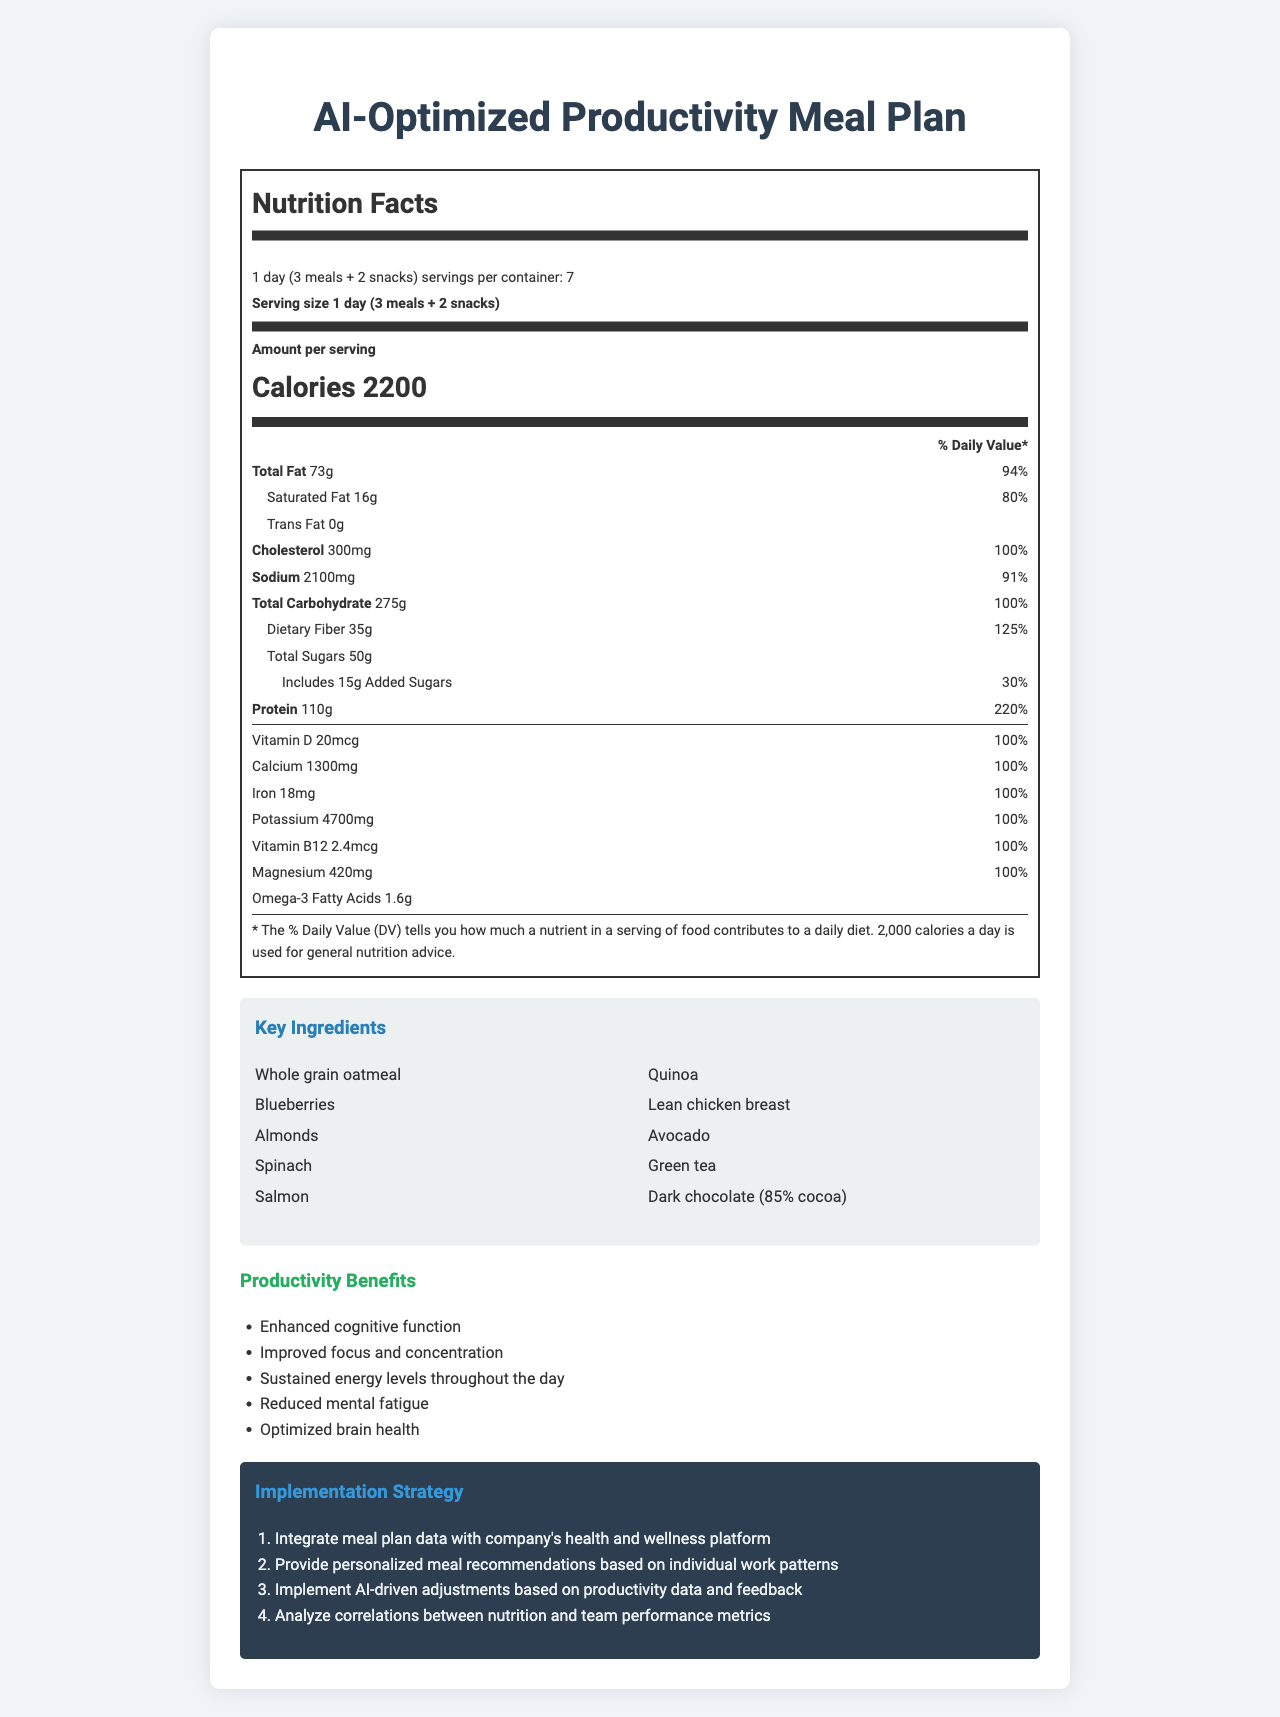what is the serving size for the AI-Optimized Productivity Meal Plan? The serving size is specified in the document under "Nutrition Facts" as "1 day (3 meals + 2 snacks)".
Answer: 1 day (3 meals + 2 snacks) How many calories are there per serving? According to the document, each serving contains 2200 calories.
Answer: 2200 What is the total amount of protein in one serving, and what percentage of the daily value does it represent? The protein amount per serving is listed as 110g with a daily value percentage of 220%.
Answer: 110g and 220% Which key ingredient is rich in Omega-3 fatty acids? Salmon is specifically mentioned as providing Omega-3 fatty acids as part of the key ingredients.
Answer: Salmon What are the AI recommendations for the afternoon snack? The AI recommendations for the afternoon snack include green tea and dark chocolate for improved focus.
Answer: Green tea and dark chocolate for improved focus How much dietary fiber is in one serving, and what is its daily value percentage? Dietary fiber is listed in the document as 35g per serving, which represents 125% of the daily value.
Answer: 35g and 125% How many servings per container are there? A. 5 B. 6 C. 7 D. 8 The document specifies that there are 7 servings per container.
Answer: C. 7 Which of the following is NOT listed as one of the productivity benefits? A. Reduced mental fatigue B. Improved physical performance C. Enhanced cognitive function D. Sustained energy levels The listed productivity benefits include A, C, and D but do not mention improved physical performance.
Answer: B. Improved physical performance Does the meal plan accommodate vegan dietary restrictions? Yes/No The customization options include vegan dietary restrictions.
Answer: Yes Summarize the purpose and primary contents of the document. The document provides comprehensive information about the nutritional composition and benefits of the AI-recommended meal plan, outlines personalized meal suggestions for enhanced productivity, and details the strategy for integrating the meal plan into a company’s wellness platform.
Answer: The document describes the AI-Optimized Productivity Meal Plan, including its nutrition facts, key ingredients, AI recommendations for meals and snacks, productivity benefits, tracking methods for effectiveness, and steps for implementation. What is the cost of the AI-Optimized Productivity Meal Plan per container? The document does not provide any information regarding the cost of the meal plan.
Answer: Not enough information 